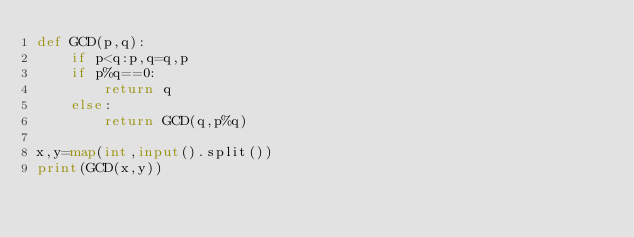<code> <loc_0><loc_0><loc_500><loc_500><_Python_>def GCD(p,q):
    if p<q:p,q=q,p
    if p%q==0:
        return q
    else:
        return GCD(q,p%q)

x,y=map(int,input().split())
print(GCD(x,y))
</code> 